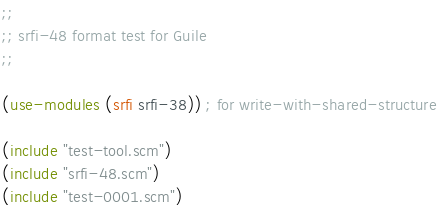Convert code to text. <code><loc_0><loc_0><loc_500><loc_500><_Scheme_>;;
;; srfi-48 format test for Guile
;;

(use-modules (srfi srfi-38)) ; for write-with-shared-structure

(include "test-tool.scm")
(include "srfi-48.scm")
(include "test-0001.scm")

</code> 